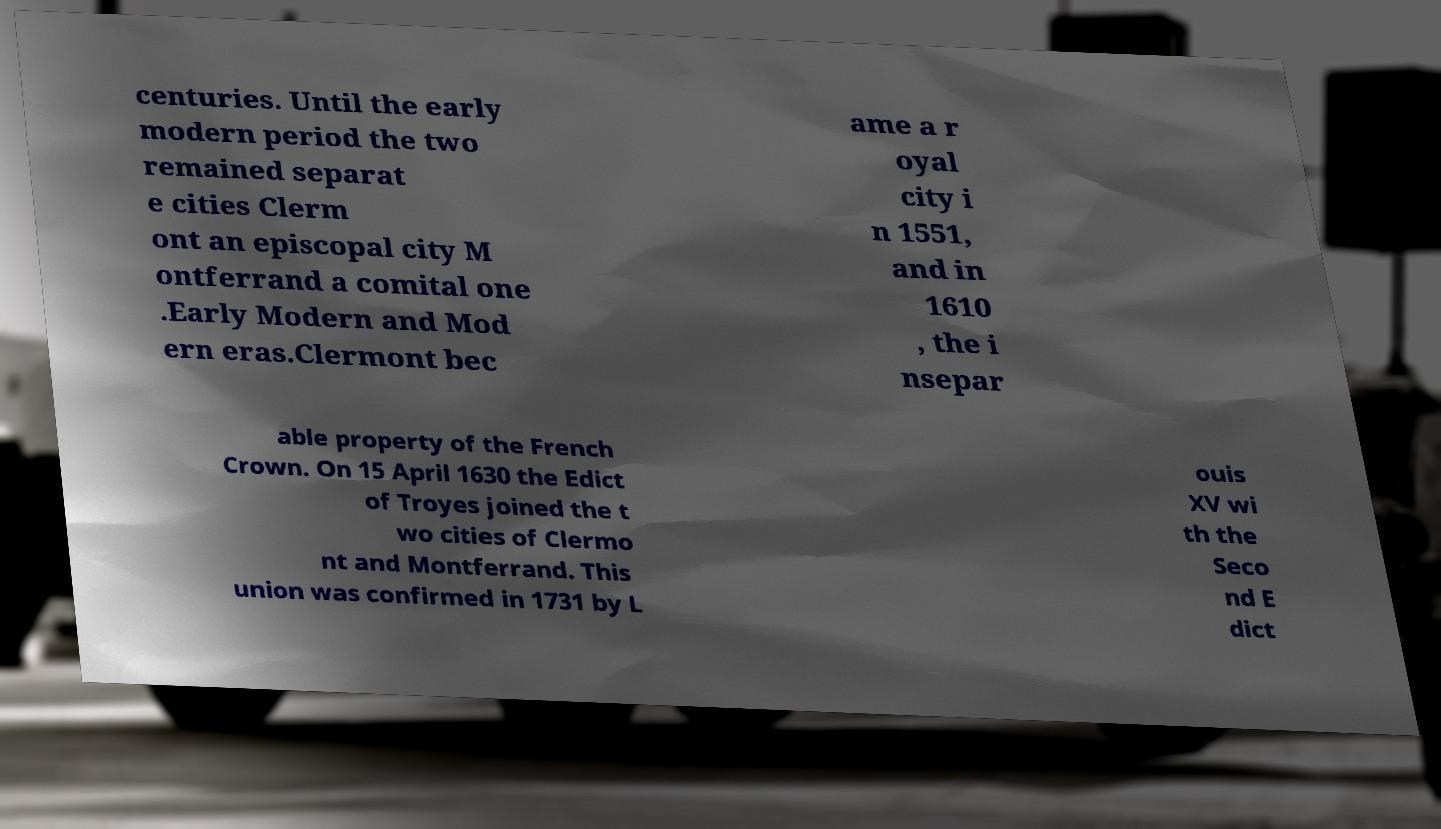Can you read and provide the text displayed in the image?This photo seems to have some interesting text. Can you extract and type it out for me? centuries. Until the early modern period the two remained separat e cities Clerm ont an episcopal city M ontferrand a comital one .Early Modern and Mod ern eras.Clermont bec ame a r oyal city i n 1551, and in 1610 , the i nsepar able property of the French Crown. On 15 April 1630 the Edict of Troyes joined the t wo cities of Clermo nt and Montferrand. This union was confirmed in 1731 by L ouis XV wi th the Seco nd E dict 